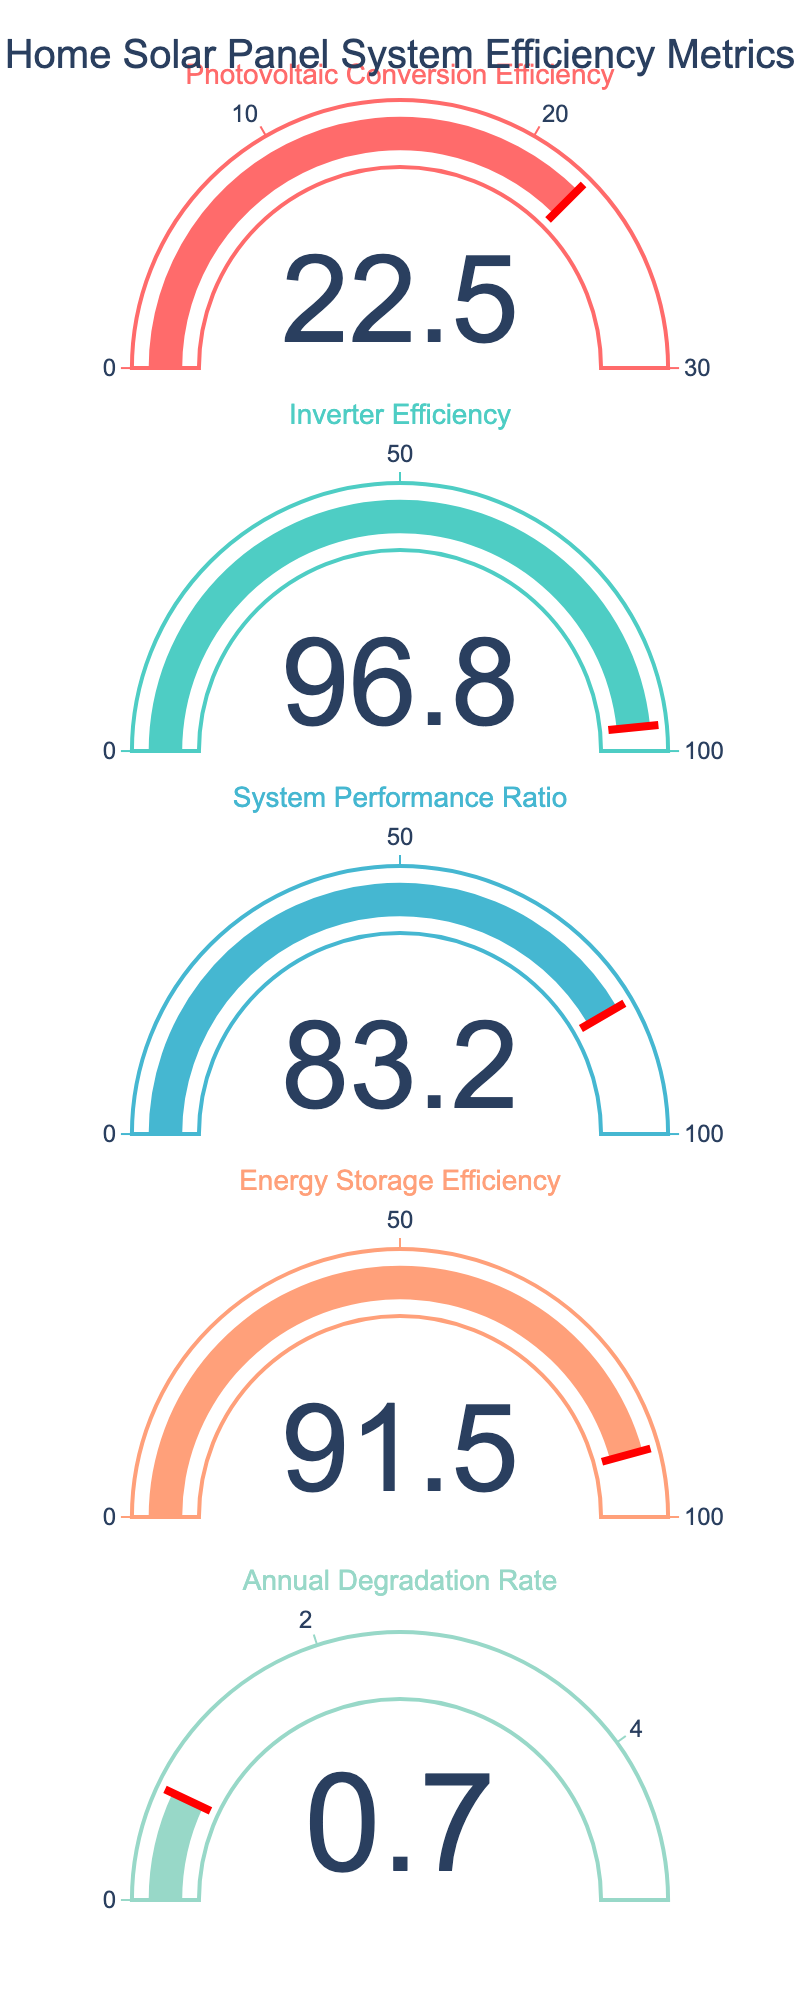What is the title of the gauge chart? The title of the chart is found at the top and is usually in larger text than other elements.
Answer: Home Solar Panel System Efficiency Metrics What is the value of Photovoltaic Conversion Efficiency? The value is displayed on the gauge labeled 'Photovoltaic Conversion Efficiency.'
Answer: 22.5 Which efficiency metric has the highest value? Compare the displayed values of all the efficiency metrics. The highest value is 96.8 which belongs to 'Inverter Efficiency.'
Answer: Inverter Efficiency What is the range of the gauge for System Performance Ratio? The range for each metric is shown by the axis on the gauge. For 'System Performance Ratio,' it goes from 0 to 100.
Answer: 0 to 100 How does the value of Energy Storage Efficiency compare to the System Performance Ratio? Compare the values displayed on the gauges for both 'Energy Storage Efficiency' and 'System Performance Ratio.' 91.5 (Energy Storage Efficiency) is greater than 83.2 (System Performance Ratio).
Answer: Greater than What is the approximate difference between Inverter Efficiency and Annual Degradation Rate? Subtract the value of 'Annual Degradation Rate' from 'Inverter Efficiency': 96.8 - 0.7 = 96.1.
Answer: 96.1 If we average the values of Inverter Efficiency, System Performance Ratio, and Energy Storage Efficiency, what is the result? Sum the values (96.8 + 83.2 + 91.5) and then divide by the number of metrics (3): (96.8 + 83.2 + 91.5) / 3 = 90.5.
Answer: 90.5 Which metric has the smallest value, and what is that value? By comparing all the values, the metric with the smallest value is the 'Annual Degradation Rate' at 0.7.
Answer: Annual Degradation Rate at 0.7 Is the Photovoltaic Conversion Efficiency value closer to the minimum or maximum of its range? Compare 22.5 to the range (0 to 30). It is closer to the maximum (30 - 22.5 = 7.5) than the minimum (22.5 - 0 = 22.5).
Answer: Closer to maximum What is the combined total of the values from all five metrics? Sum all the values: 22.5 (Photovoltaic Conversion Efficiency) + 96.8 (Inverter Efficiency) + 83.2 (System Performance Ratio) + 91.5 (Energy Storage Efficiency) + 0.7 (Annual Degradation Rate) = 294.7.
Answer: 294.7 